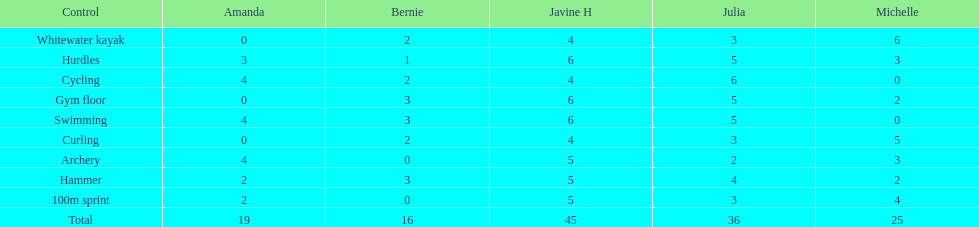What other girl besides amanda also had a 4 in cycling? Javine H. 